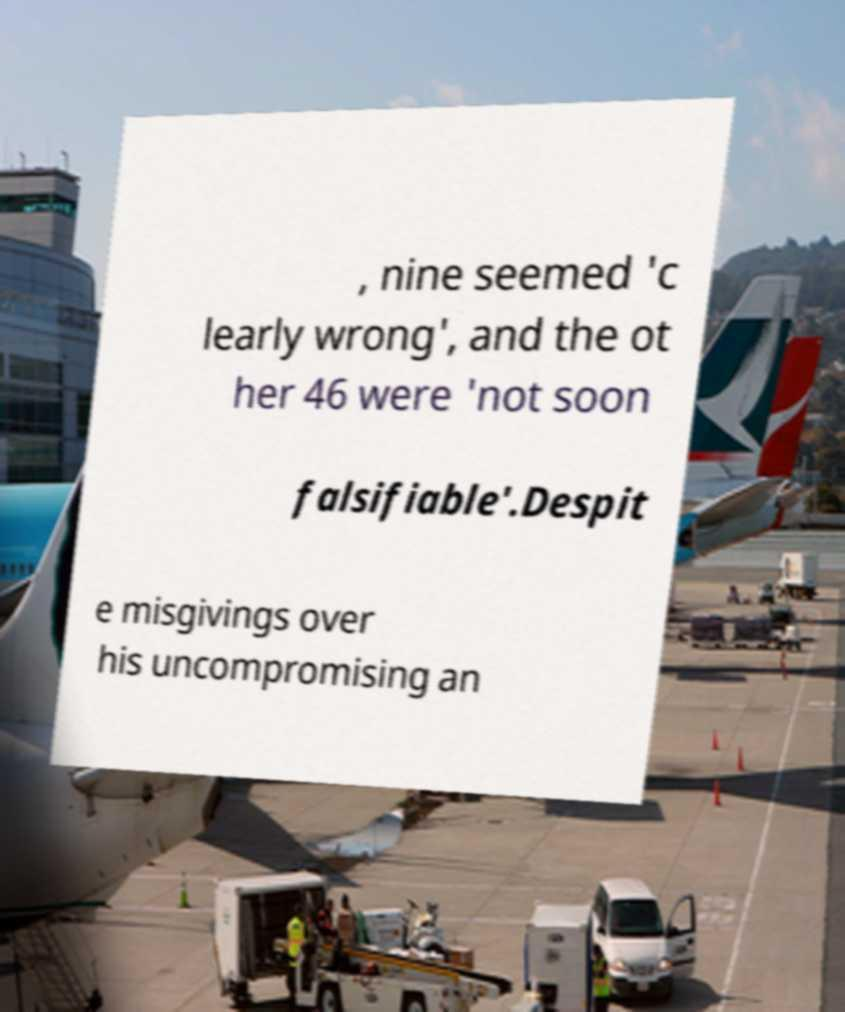Could you extract and type out the text from this image? , nine seemed 'c learly wrong', and the ot her 46 were 'not soon falsifiable'.Despit e misgivings over his uncompromising an 